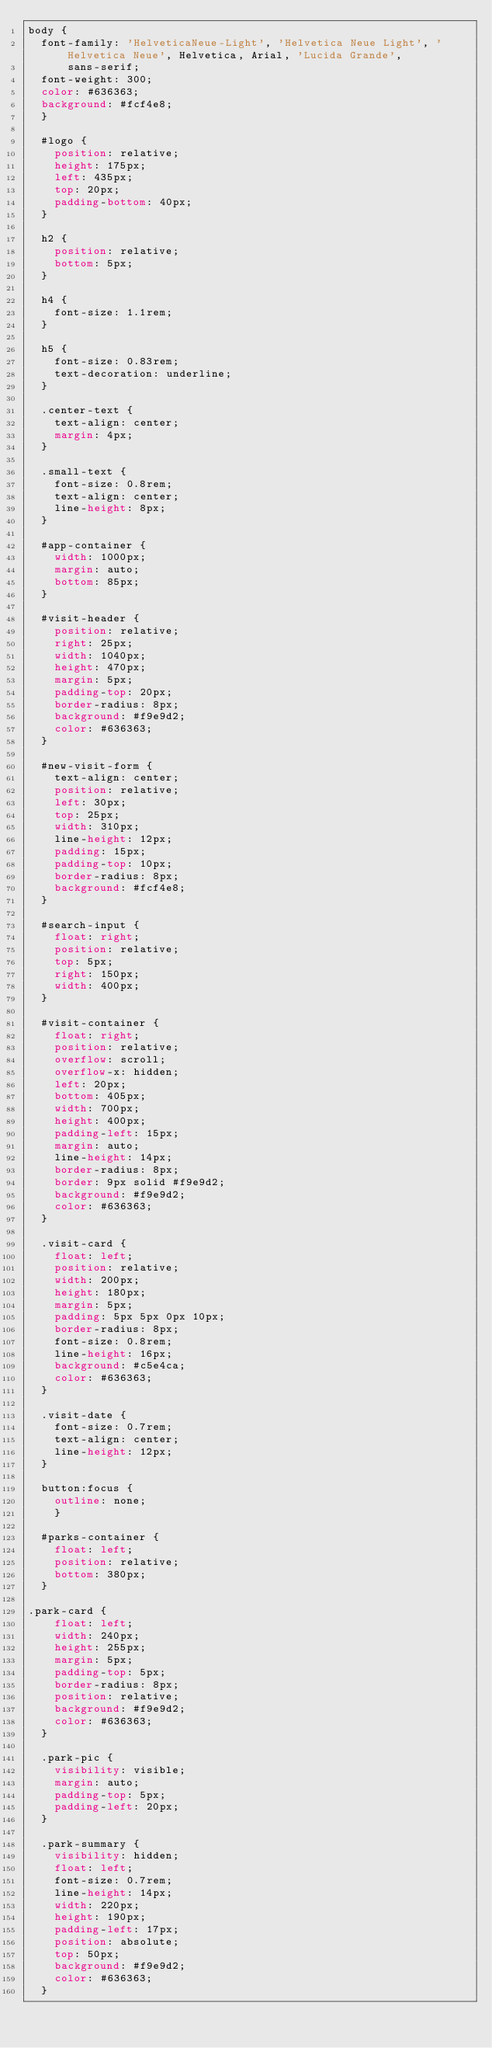Convert code to text. <code><loc_0><loc_0><loc_500><loc_500><_CSS_>body {
  font-family: 'HelveticaNeue-Light', 'Helvetica Neue Light', 'Helvetica Neue', Helvetica, Arial, 'Lucida Grande',
      sans-serif;
  font-weight: 300;
  color: #636363;
  background: #fcf4e8;
  }

  #logo {
    position: relative;
    height: 175px;
    left: 435px;
    top: 20px;
    padding-bottom: 40px;
  }

  h2 {
    position: relative;
    bottom: 5px;
  }
  
  h4 {
    font-size: 1.1rem;
  }

  h5 {
    font-size: 0.83rem;
    text-decoration: underline;
  }
  
  .center-text {
    text-align: center;
    margin: 4px;
  }
  
  .small-text {
    font-size: 0.8rem;
    text-align: center;
    line-height: 8px;
  }
  
  #app-container {
    width: 1000px;
    margin: auto;
    bottom: 85px;
  }

  #visit-header {
    position: relative;
    right: 25px;
    width: 1040px;
    height: 470px;
    margin: 5px;
    padding-top: 20px;
    border-radius: 8px;
    background: #f9e9d2;
    color: #636363;
  }

  #new-visit-form {
    text-align: center;
    position: relative;
    left: 30px;
    top: 25px;
    width: 310px;
    line-height: 12px;
    padding: 15px;
    padding-top: 10px;
    border-radius: 8px;
    background: #fcf4e8;
  }

  #search-input {
    float: right;
    position: relative;
    top: 5px;
    right: 150px;
    width: 400px;
  }

  #visit-container {
    float: right;
    position: relative;
    overflow: scroll;
    overflow-x: hidden;
    left: 20px;
    bottom: 405px;
    width: 700px;
    height: 400px;
    padding-left: 15px;
    margin: auto;
    line-height: 14px;
    border-radius: 8px;
    border: 9px solid #f9e9d2;
    background: #f9e9d2;
    color: #636363;
  }

  .visit-card {
    float: left;
    position: relative;
    width: 200px;
    height: 180px;
    margin: 5px;
    padding: 5px 5px 0px 10px;
    border-radius: 8px;
    font-size: 0.8rem;
    line-height: 16px;
    background: #c5e4ca;
    color: #636363;
  }

  .visit-date {
    font-size: 0.7rem;
    text-align: center;
    line-height: 12px;
  }

  button:focus {
    outline: none;
    }

  #parks-container {
    float: left;
    position: relative;
    bottom: 380px;
  }

.park-card {
    float: left;
    width: 240px;
    height: 255px;
    margin: 5px;
    padding-top: 5px;
    border-radius: 8px;
    position: relative;
    background: #f9e9d2;
    color: #636363;
  }
  
  .park-pic {
    visibility: visible;
    margin: auto;
    padding-top: 5px;
    padding-left: 20px;
  }
  
  .park-summary {
    visibility: hidden; 
    float: left;
    font-size: 0.7rem;
    line-height: 14px;
    width: 220px;
    height: 190px;
    padding-left: 17px;
    position: absolute;
    top: 50px;
    background: #f9e9d2;
    color: #636363;
  }</code> 